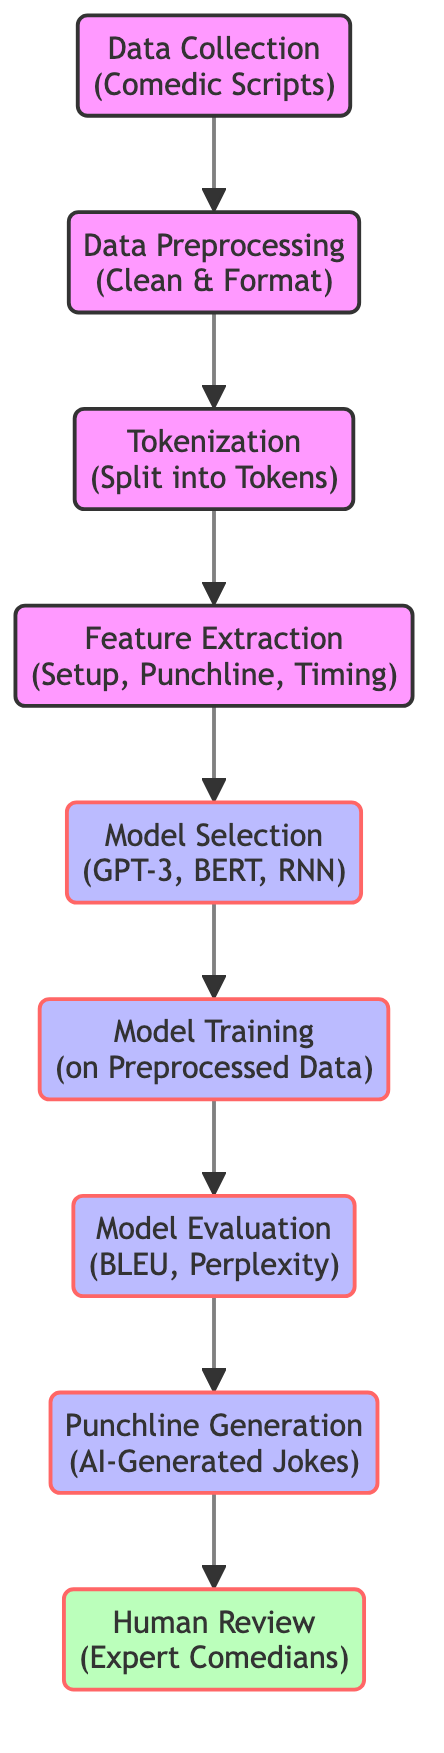What is the first step in the diagram? The first step in the diagram is "Data Collection". This can be identified as it is the topmost node in the flowchart, which indicates the starting point of the process.
Answer: Data Collection How many nodes are displayed in the diagram? To find the number of nodes, we can count each unique labeled shape in the diagram, including "Data Collection", "Data Preprocessing", "Tokenization", "Feature Extraction", "Model Selection", "Model Training", "Model Evaluation", "Punchline Generation", and "Human Review". There are 9 nodes in total.
Answer: 9 What process follows "Tokenization" in the flowchart? The process that follows "Tokenization" is "Feature Extraction". This can be determined by tracing the arrow from the "Tokenization" node to the next node, which clearly indicates the next step in the workflow.
Answer: Feature Extraction Which step involves expert comedians? The step that involves expert comedians is "Human Review". This node signifies that after the AI-generated jokes, they are reviewed by human experts in comedy to assess their quality.
Answer: Human Review What output does the diagram produce after "Model Evaluation"? After "Model Evaluation", the output produced is "Punchline Generation". This implies that the evaluation step is crucial in determining whether the trained model can successfully generate jokes.
Answer: Punchline Generation What is the relationship between "Model Training" and "Model Selection"? The relationship between "Model Training" and "Model Selection" is sequential; "Model Selection" is completed before "Model Training". The diagram shows that you must first select a model before initiating the training process on the preprocessed data.
Answer: Sequential What are the evaluation metrics used in the diagram? The evaluation metrics mentioned in the diagram are "BLEU" and "Perplexity". These are standard metrics in natural language processing to measure the performance of generated text.
Answer: BLEU, Perplexity Which part of the diagram indicates a decision-making process? The "Model Selection" part of the diagram indicates a decision-making process. This is evident as it suggests choosing between different algorithms or models (like GPT-3, BERT, RNN) based on their suitability for the task.
Answer: Model Selection What is the ultimate goal represented in the diagram? The ultimate goal represented in the diagram is "Punchline Generation". This is the final output of the processes leading from data collection through to human review, demonstrating the end product of this training workflow.
Answer: Punchline Generation 